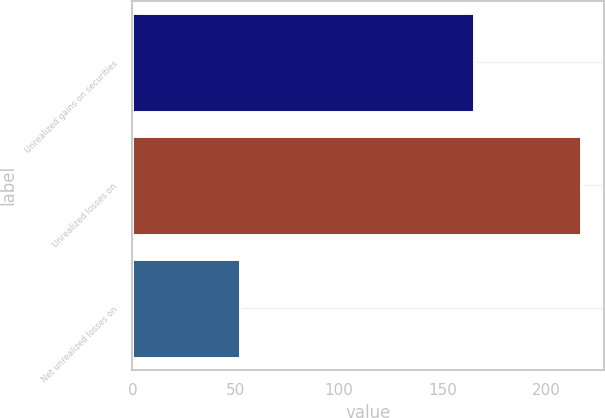Convert chart to OTSL. <chart><loc_0><loc_0><loc_500><loc_500><bar_chart><fcel>Unrealized gains on securities<fcel>Unrealized losses on<fcel>Net unrealized losses on<nl><fcel>165<fcel>217<fcel>52<nl></chart> 